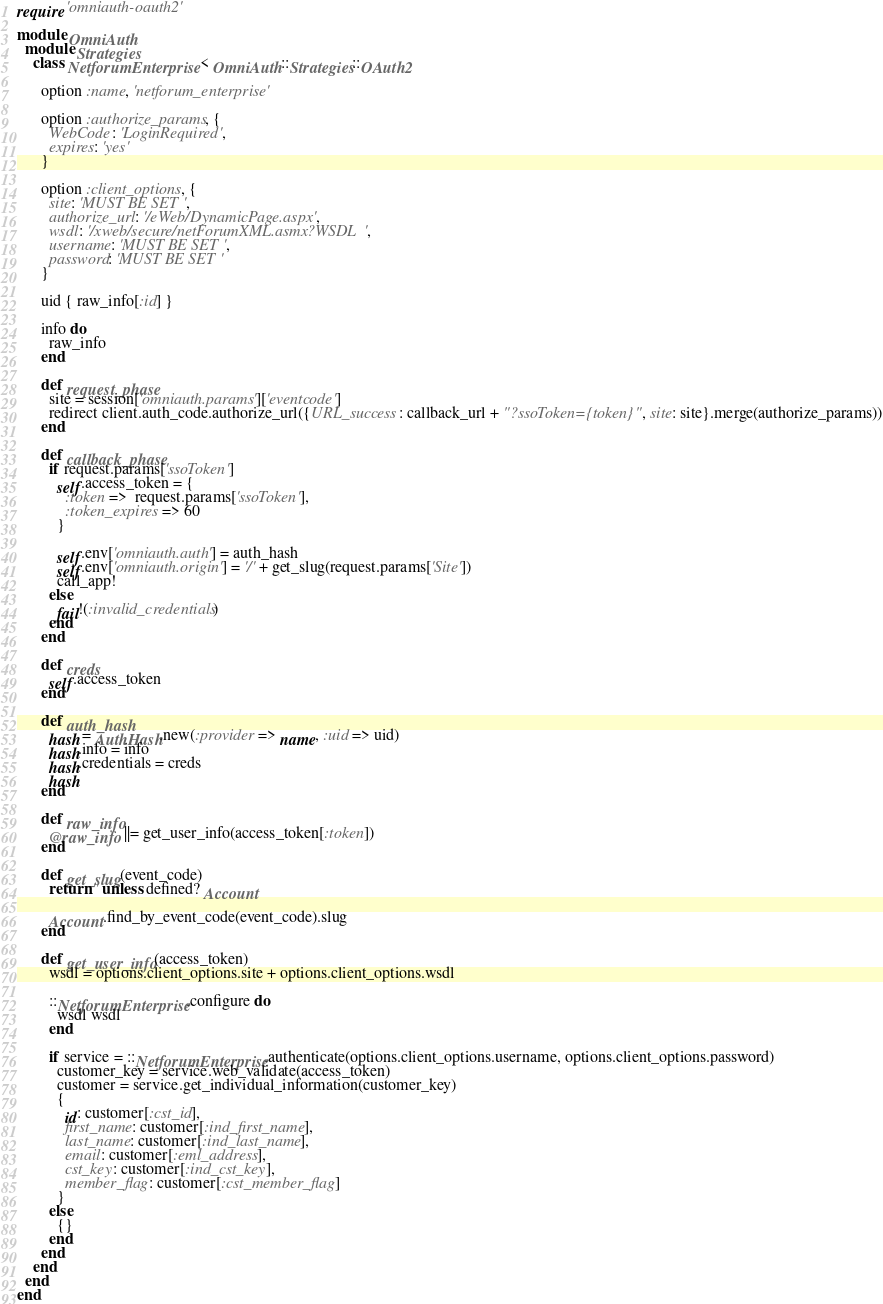Convert code to text. <code><loc_0><loc_0><loc_500><loc_500><_Ruby_>require 'omniauth-oauth2'

module OmniAuth
  module Strategies
    class NetforumEnterprise < OmniAuth::Strategies::OAuth2

      option :name, 'netforum_enterprise'

      option :authorize_params, {
        WebCode: 'LoginRequired',
        expires: 'yes'
      }

      option :client_options, {
        site: 'MUST BE SET',
        authorize_url: '/eWeb/DynamicPage.aspx',
        wsdl: '/xweb/secure/netForumXML.asmx?WSDL',
        username: 'MUST BE SET',
        password: 'MUST BE SET'
      }

      uid { raw_info[:id] }

      info do
        raw_info
      end

      def request_phase
        site = session['omniauth.params']['eventcode']
        redirect client.auth_code.authorize_url({URL_success: callback_url + "?ssoToken={token}", site: site}.merge(authorize_params))
      end

      def callback_phase
        if request.params['ssoToken']
          self.access_token = {
            :token =>  request.params['ssoToken'],
            :token_expires => 60
          }

          self.env['omniauth.auth'] = auth_hash
          self.env['omniauth.origin'] = '/' + get_slug(request.params['Site'])
          call_app!
        else
          fail!(:invalid_credentials)
        end
      end

      def creds
        self.access_token
      end

      def auth_hash
        hash = AuthHash.new(:provider => name, :uid => uid)
        hash.info = info
        hash.credentials = creds
        hash
      end

      def raw_info
        @raw_info ||= get_user_info(access_token[:token])
      end

      def get_slug(event_code)
        return '' unless defined? Account

        Account.find_by_event_code(event_code).slug
      end

      def get_user_info(access_token)
        wsdl = options.client_options.site + options.client_options.wsdl

        ::NetforumEnterprise.configure do
          wsdl wsdl
        end

        if service = ::NetforumEnterprise.authenticate(options.client_options.username, options.client_options.password)
          customer_key = service.web_validate(access_token)
          customer = service.get_individual_information(customer_key)
          {
            id: customer[:cst_id],
            first_name: customer[:ind_first_name],
            last_name: customer[:ind_last_name],
            email: customer[:eml_address],
            cst_key: customer[:ind_cst_key],
            member_flag: customer[:cst_member_flag]
          }
        else
          {}
        end
      end
    end
  end
end
</code> 